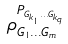Convert formula to latex. <formula><loc_0><loc_0><loc_500><loc_500>\rho _ { G _ { 1 } \dots G _ { m } } ^ { P _ { G _ { k _ { 1 } } \dots G _ { k _ { q } } } }</formula> 